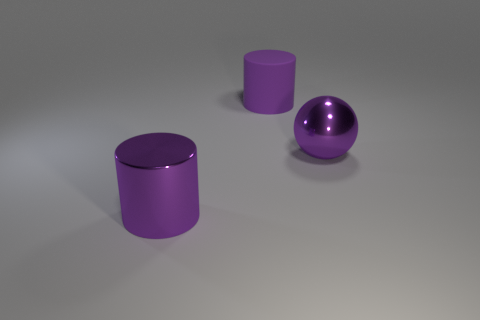There is a large metal object that is on the right side of the rubber thing; what is its shape?
Your answer should be compact. Sphere. There is another object that is the same shape as the matte object; what size is it?
Provide a succinct answer. Large. Do the metallic ball and the big matte cylinder have the same color?
Provide a succinct answer. Yes. Are there any large purple cylinders that are behind the metallic object right of the metal cylinder?
Offer a very short reply. Yes. What color is the metal object that is the same shape as the purple matte thing?
Ensure brevity in your answer.  Purple. How many other metal cylinders are the same color as the large shiny cylinder?
Your answer should be very brief. 0. There is a large cylinder behind the metallic cylinder that is left of the big purple cylinder that is behind the large shiny cylinder; what color is it?
Keep it short and to the point. Purple. Are there an equal number of large metallic cylinders that are behind the purple metallic sphere and large rubber cylinders behind the purple metallic cylinder?
Offer a terse response. No. There is a big cylinder that is the same material as the purple sphere; what is its color?
Provide a succinct answer. Purple. What number of other big purple spheres have the same material as the large purple sphere?
Your answer should be compact. 0. 